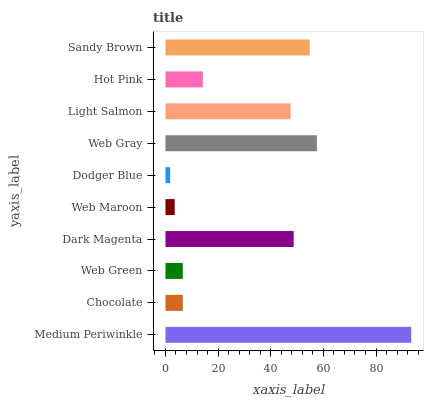Is Dodger Blue the minimum?
Answer yes or no. Yes. Is Medium Periwinkle the maximum?
Answer yes or no. Yes. Is Chocolate the minimum?
Answer yes or no. No. Is Chocolate the maximum?
Answer yes or no. No. Is Medium Periwinkle greater than Chocolate?
Answer yes or no. Yes. Is Chocolate less than Medium Periwinkle?
Answer yes or no. Yes. Is Chocolate greater than Medium Periwinkle?
Answer yes or no. No. Is Medium Periwinkle less than Chocolate?
Answer yes or no. No. Is Light Salmon the high median?
Answer yes or no. Yes. Is Hot Pink the low median?
Answer yes or no. Yes. Is Sandy Brown the high median?
Answer yes or no. No. Is Medium Periwinkle the low median?
Answer yes or no. No. 